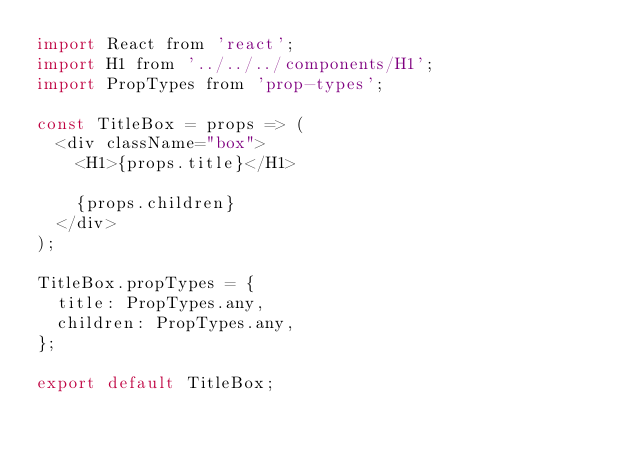<code> <loc_0><loc_0><loc_500><loc_500><_JavaScript_>import React from 'react';
import H1 from '../../../components/H1';
import PropTypes from 'prop-types';

const TitleBox = props => (
  <div className="box">
    <H1>{props.title}</H1>

    {props.children}
  </div>
);

TitleBox.propTypes = {
  title: PropTypes.any,
  children: PropTypes.any,
};

export default TitleBox;
</code> 